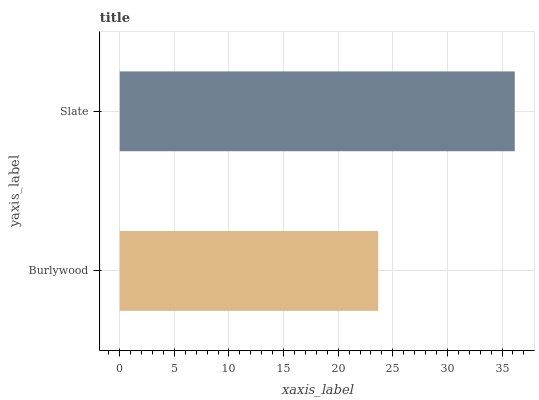Is Burlywood the minimum?
Answer yes or no. Yes. Is Slate the maximum?
Answer yes or no. Yes. Is Slate the minimum?
Answer yes or no. No. Is Slate greater than Burlywood?
Answer yes or no. Yes. Is Burlywood less than Slate?
Answer yes or no. Yes. Is Burlywood greater than Slate?
Answer yes or no. No. Is Slate less than Burlywood?
Answer yes or no. No. Is Slate the high median?
Answer yes or no. Yes. Is Burlywood the low median?
Answer yes or no. Yes. Is Burlywood the high median?
Answer yes or no. No. Is Slate the low median?
Answer yes or no. No. 